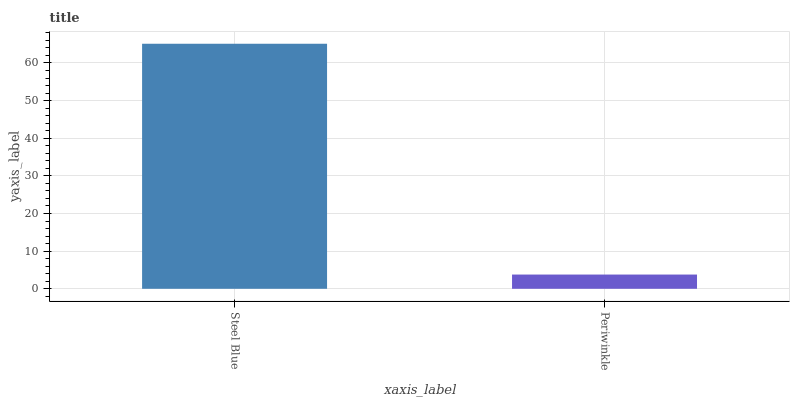Is Periwinkle the minimum?
Answer yes or no. Yes. Is Steel Blue the maximum?
Answer yes or no. Yes. Is Periwinkle the maximum?
Answer yes or no. No. Is Steel Blue greater than Periwinkle?
Answer yes or no. Yes. Is Periwinkle less than Steel Blue?
Answer yes or no. Yes. Is Periwinkle greater than Steel Blue?
Answer yes or no. No. Is Steel Blue less than Periwinkle?
Answer yes or no. No. Is Steel Blue the high median?
Answer yes or no. Yes. Is Periwinkle the low median?
Answer yes or no. Yes. Is Periwinkle the high median?
Answer yes or no. No. Is Steel Blue the low median?
Answer yes or no. No. 